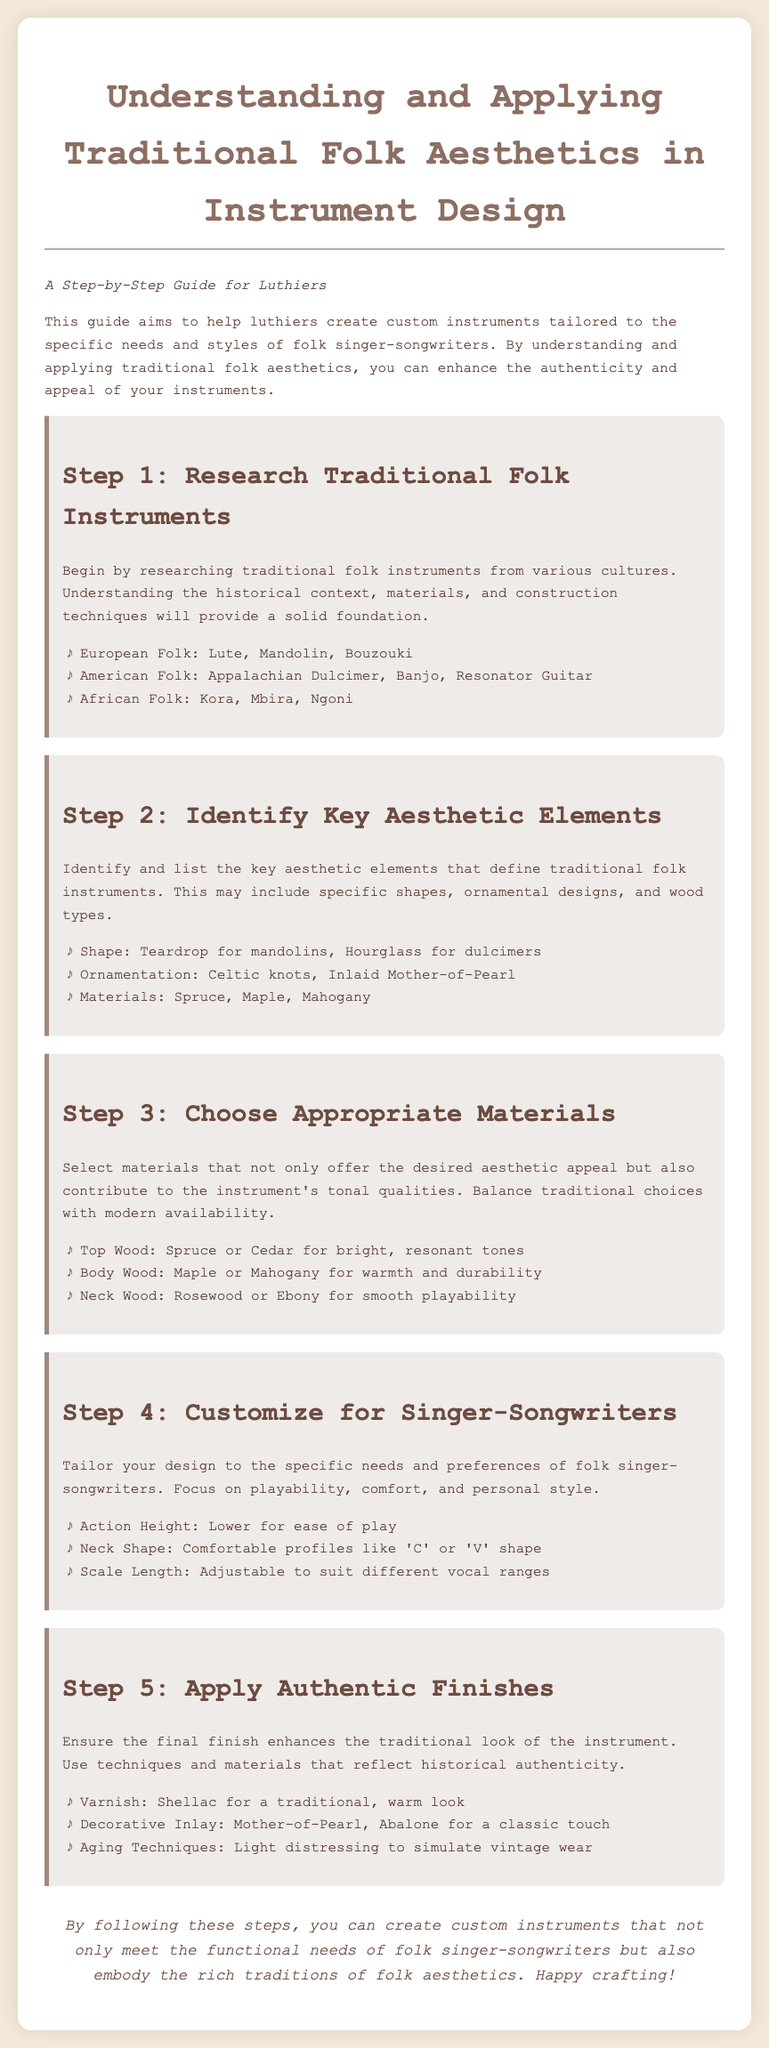What is the title of the guide? The title of the guide is prominently displayed at the top of the document, indicating its focus on traditional folk aesthetics in instrument design.
Answer: Understanding and Applying Traditional Folk Aesthetics in Instrument Design How many steps are outlined in the guide? The guide is structured into distinct steps, clearly numbered and presented, totaling five in the content.
Answer: 5 What is the primary focus of Step 4? Step 4 emphasizes tailoring the instrument design specifically for the needs of folk singer-songwriters, discussing aspects like playability and comfort.
Answer: Customize for Singer-Songwriters Which wood type is suggested for a bright, resonant tone? The guide provides specific recommendations for top wood, identifying types suitable for excellent tonal qualities, specifically mentioning one that offers bright sounds.
Answer: Spruce What ornamentation is mentioned in Step 2? The guide lists specific aesthetic elements associated with traditional folk instruments, including a type of intricate design significant in the folk style.
Answer: Celtic knots What finish is recommended for a traditional look? Step 5 discusses the importance of finishes that align with historical authenticity and mentions a specific type of varnish to achieve this.
Answer: Shellac 